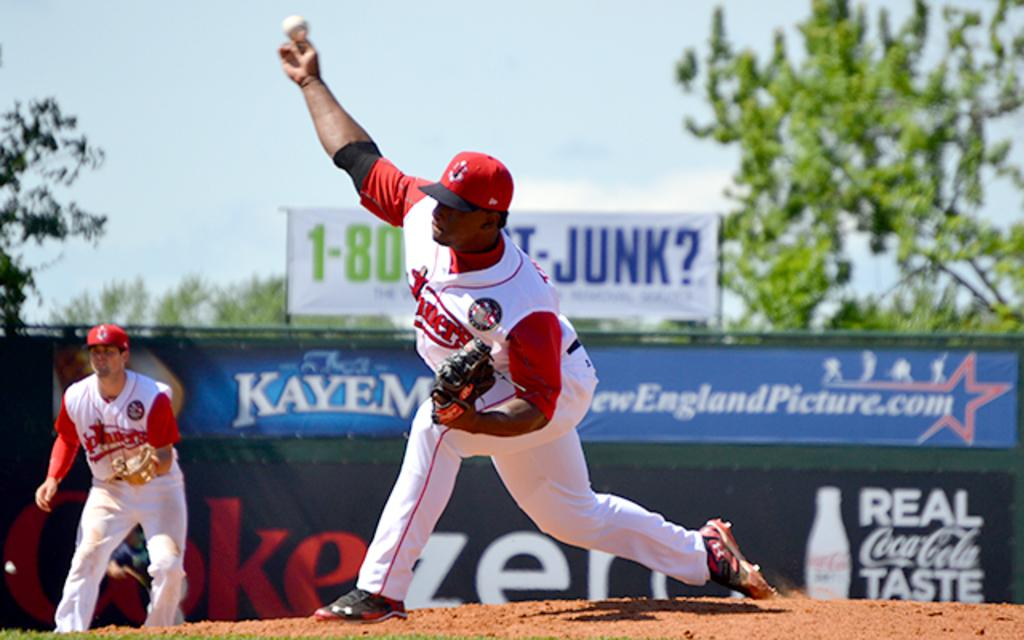<image>
Give a short and clear explanation of the subsequent image. A Coca Cola logo can be seen on a baseball diamond. 